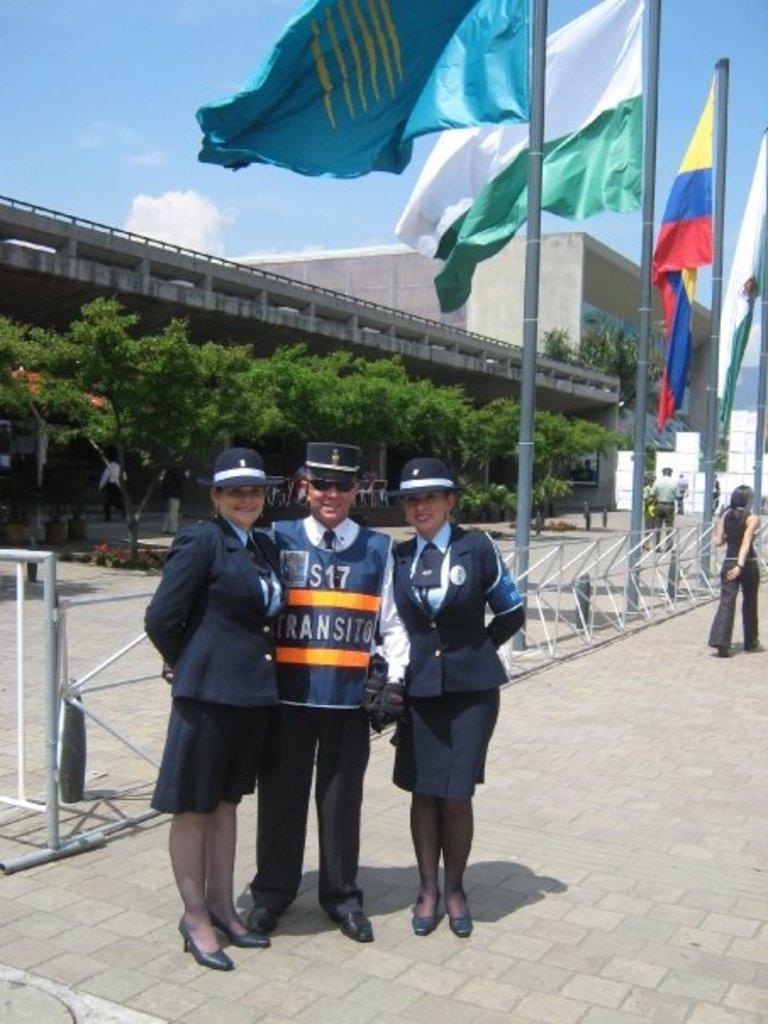Please provide a concise description of this image. In this image, we can see three persons standing and wearing clothes. There is an another person on the right side of the image. There are flags and barricades in the middle of the road. There are some trees in front of the building. There is a sky at the top of the image. 